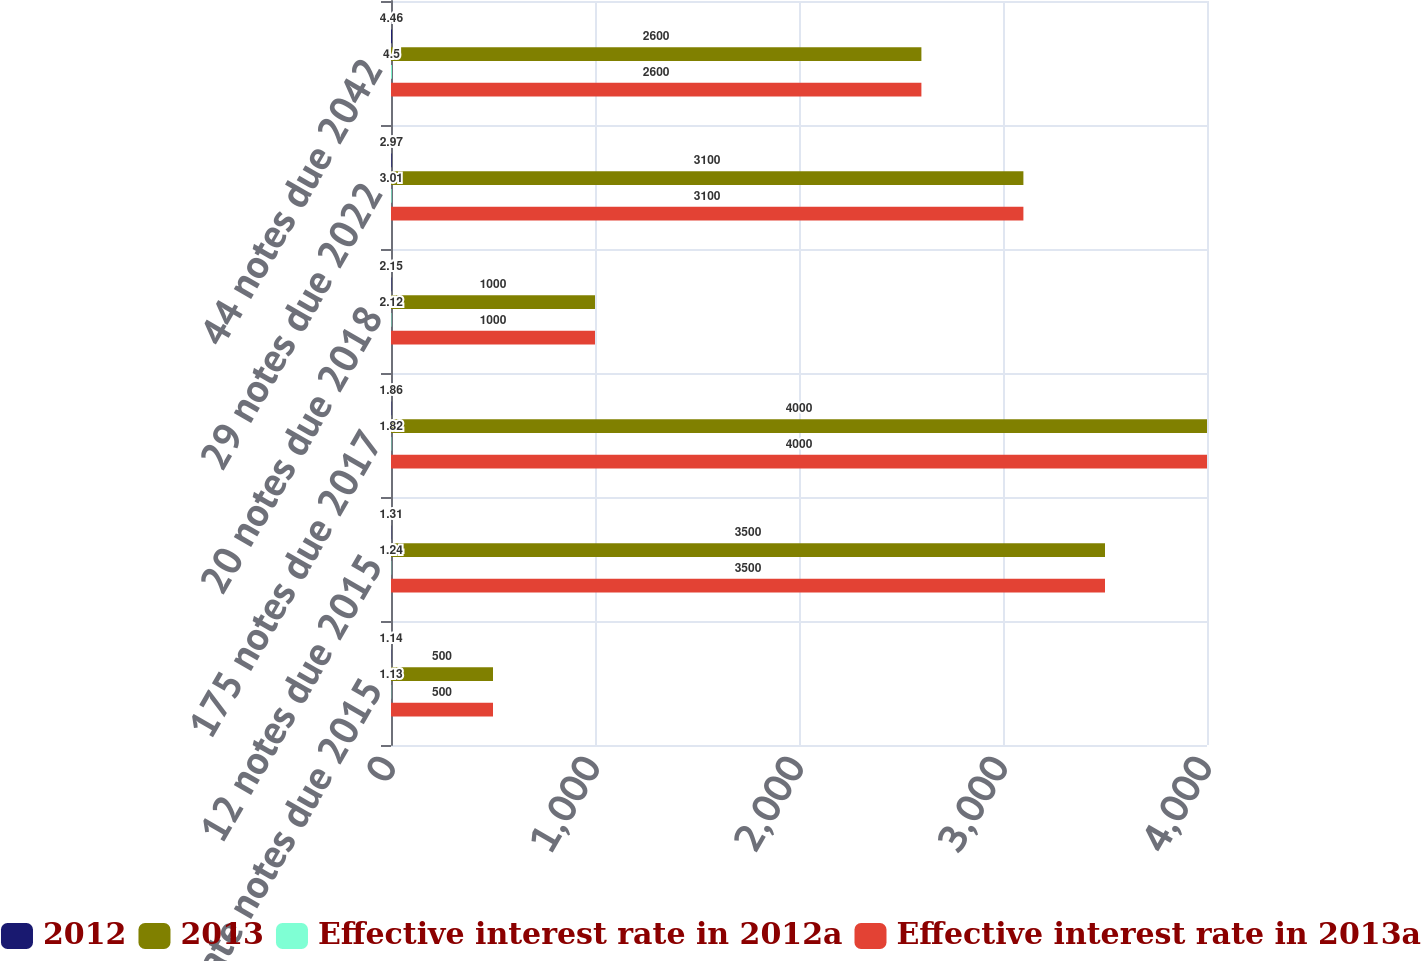Convert chart. <chart><loc_0><loc_0><loc_500><loc_500><stacked_bar_chart><ecel><fcel>Floating rate notes due 2015<fcel>12 notes due 2015<fcel>175 notes due 2017<fcel>20 notes due 2018<fcel>29 notes due 2022<fcel>44 notes due 2042<nl><fcel>2012<fcel>1.14<fcel>1.31<fcel>1.86<fcel>2.15<fcel>2.97<fcel>4.46<nl><fcel>2013<fcel>500<fcel>3500<fcel>4000<fcel>1000<fcel>3100<fcel>2600<nl><fcel>Effective interest rate in 2012a<fcel>1.13<fcel>1.24<fcel>1.82<fcel>2.12<fcel>3.01<fcel>4.5<nl><fcel>Effective interest rate in 2013a<fcel>500<fcel>3500<fcel>4000<fcel>1000<fcel>3100<fcel>2600<nl></chart> 